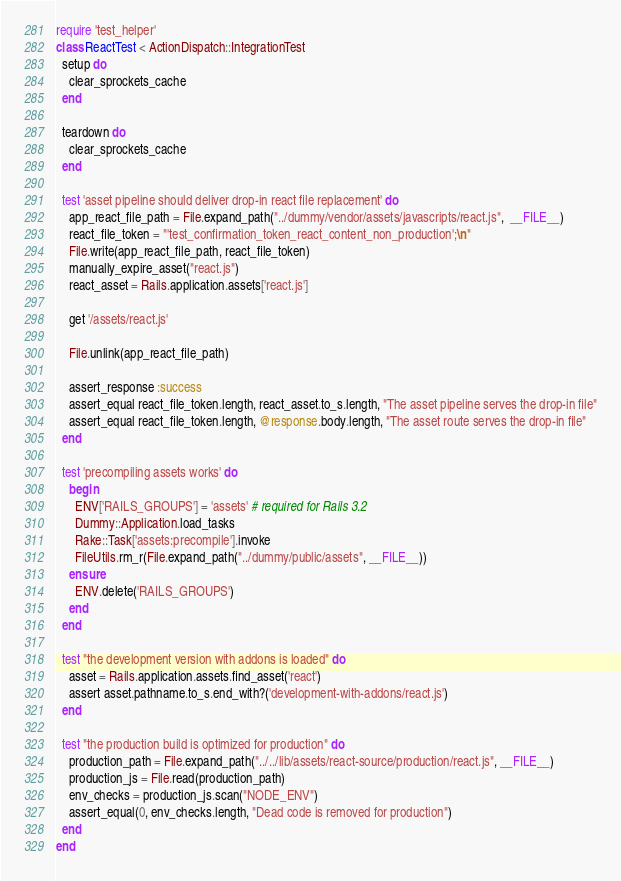Convert code to text. <code><loc_0><loc_0><loc_500><loc_500><_Ruby_>require 'test_helper'
class ReactTest < ActionDispatch::IntegrationTest
  setup do
    clear_sprockets_cache
  end

  teardown do
    clear_sprockets_cache
  end

  test 'asset pipeline should deliver drop-in react file replacement' do
    app_react_file_path = File.expand_path("../dummy/vendor/assets/javascripts/react.js",  __FILE__)
    react_file_token = "'test_confirmation_token_react_content_non_production';\n"
    File.write(app_react_file_path, react_file_token)
    manually_expire_asset("react.js")
    react_asset = Rails.application.assets['react.js']

    get '/assets/react.js'

    File.unlink(app_react_file_path)

    assert_response :success
    assert_equal react_file_token.length, react_asset.to_s.length, "The asset pipeline serves the drop-in file"
    assert_equal react_file_token.length, @response.body.length, "The asset route serves the drop-in file"
  end

  test 'precompiling assets works' do
    begin
      ENV['RAILS_GROUPS'] = 'assets' # required for Rails 3.2
      Dummy::Application.load_tasks
      Rake::Task['assets:precompile'].invoke
      FileUtils.rm_r(File.expand_path("../dummy/public/assets", __FILE__))
    ensure
      ENV.delete('RAILS_GROUPS')
    end
  end

  test "the development version with addons is loaded" do
    asset = Rails.application.assets.find_asset('react')
    assert asset.pathname.to_s.end_with?('development-with-addons/react.js')
  end

  test "the production build is optimized for production" do
    production_path = File.expand_path("../../lib/assets/react-source/production/react.js", __FILE__)
    production_js = File.read(production_path)
    env_checks = production_js.scan("NODE_ENV")
    assert_equal(0, env_checks.length, "Dead code is removed for production")
  end
end
</code> 